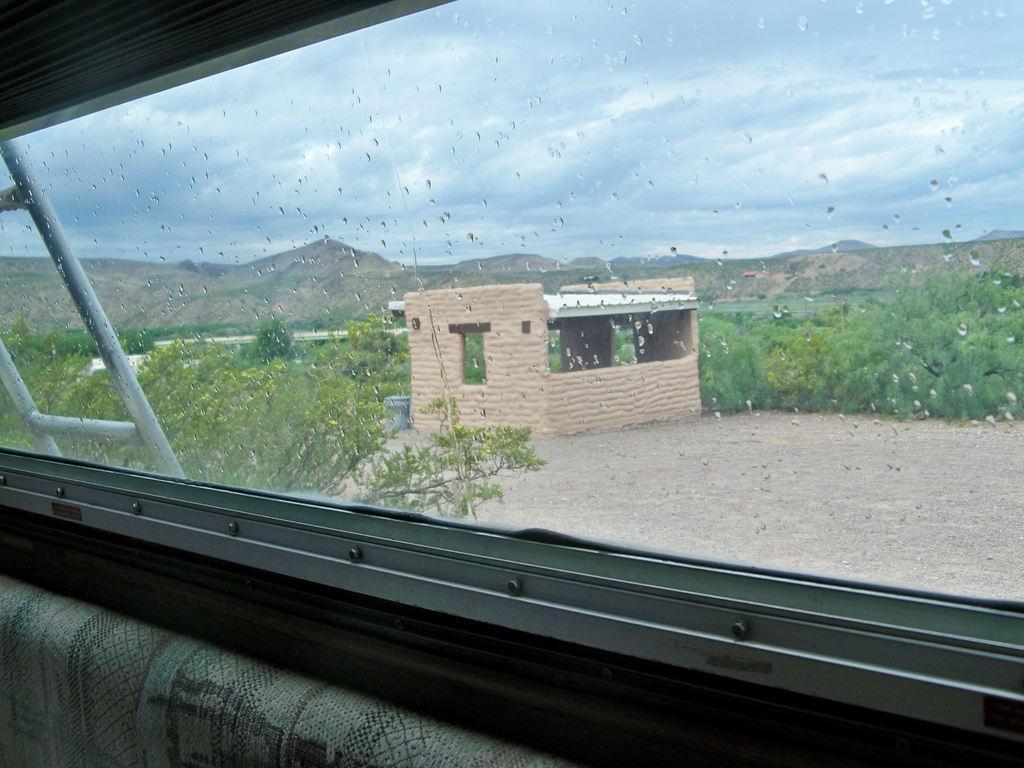Can you describe this image briefly? This image is clicked from behind the glass. There are water droplets on the glass. Outside the glass there is a small cabin on the ground. Behind the cabin there are plants and trees. In the background there are mountains. At the top there is the sky. At the bottom there are seats. 